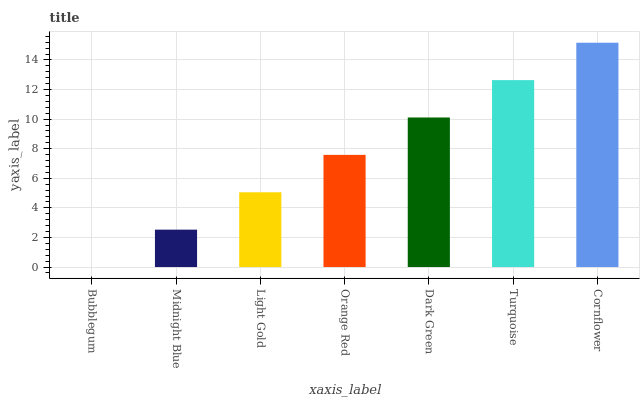Is Midnight Blue the minimum?
Answer yes or no. No. Is Midnight Blue the maximum?
Answer yes or no. No. Is Midnight Blue greater than Bubblegum?
Answer yes or no. Yes. Is Bubblegum less than Midnight Blue?
Answer yes or no. Yes. Is Bubblegum greater than Midnight Blue?
Answer yes or no. No. Is Midnight Blue less than Bubblegum?
Answer yes or no. No. Is Orange Red the high median?
Answer yes or no. Yes. Is Orange Red the low median?
Answer yes or no. Yes. Is Bubblegum the high median?
Answer yes or no. No. Is Turquoise the low median?
Answer yes or no. No. 